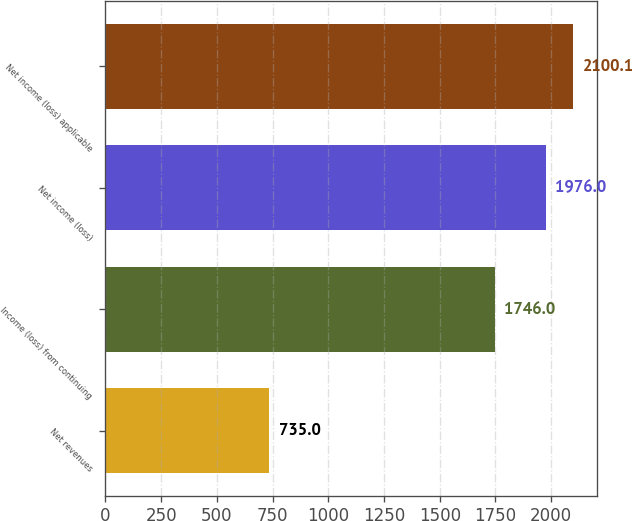Convert chart to OTSL. <chart><loc_0><loc_0><loc_500><loc_500><bar_chart><fcel>Net revenues<fcel>Income (loss) from continuing<fcel>Net income (loss)<fcel>Net income (loss) applicable<nl><fcel>735<fcel>1746<fcel>1976<fcel>2100.1<nl></chart> 